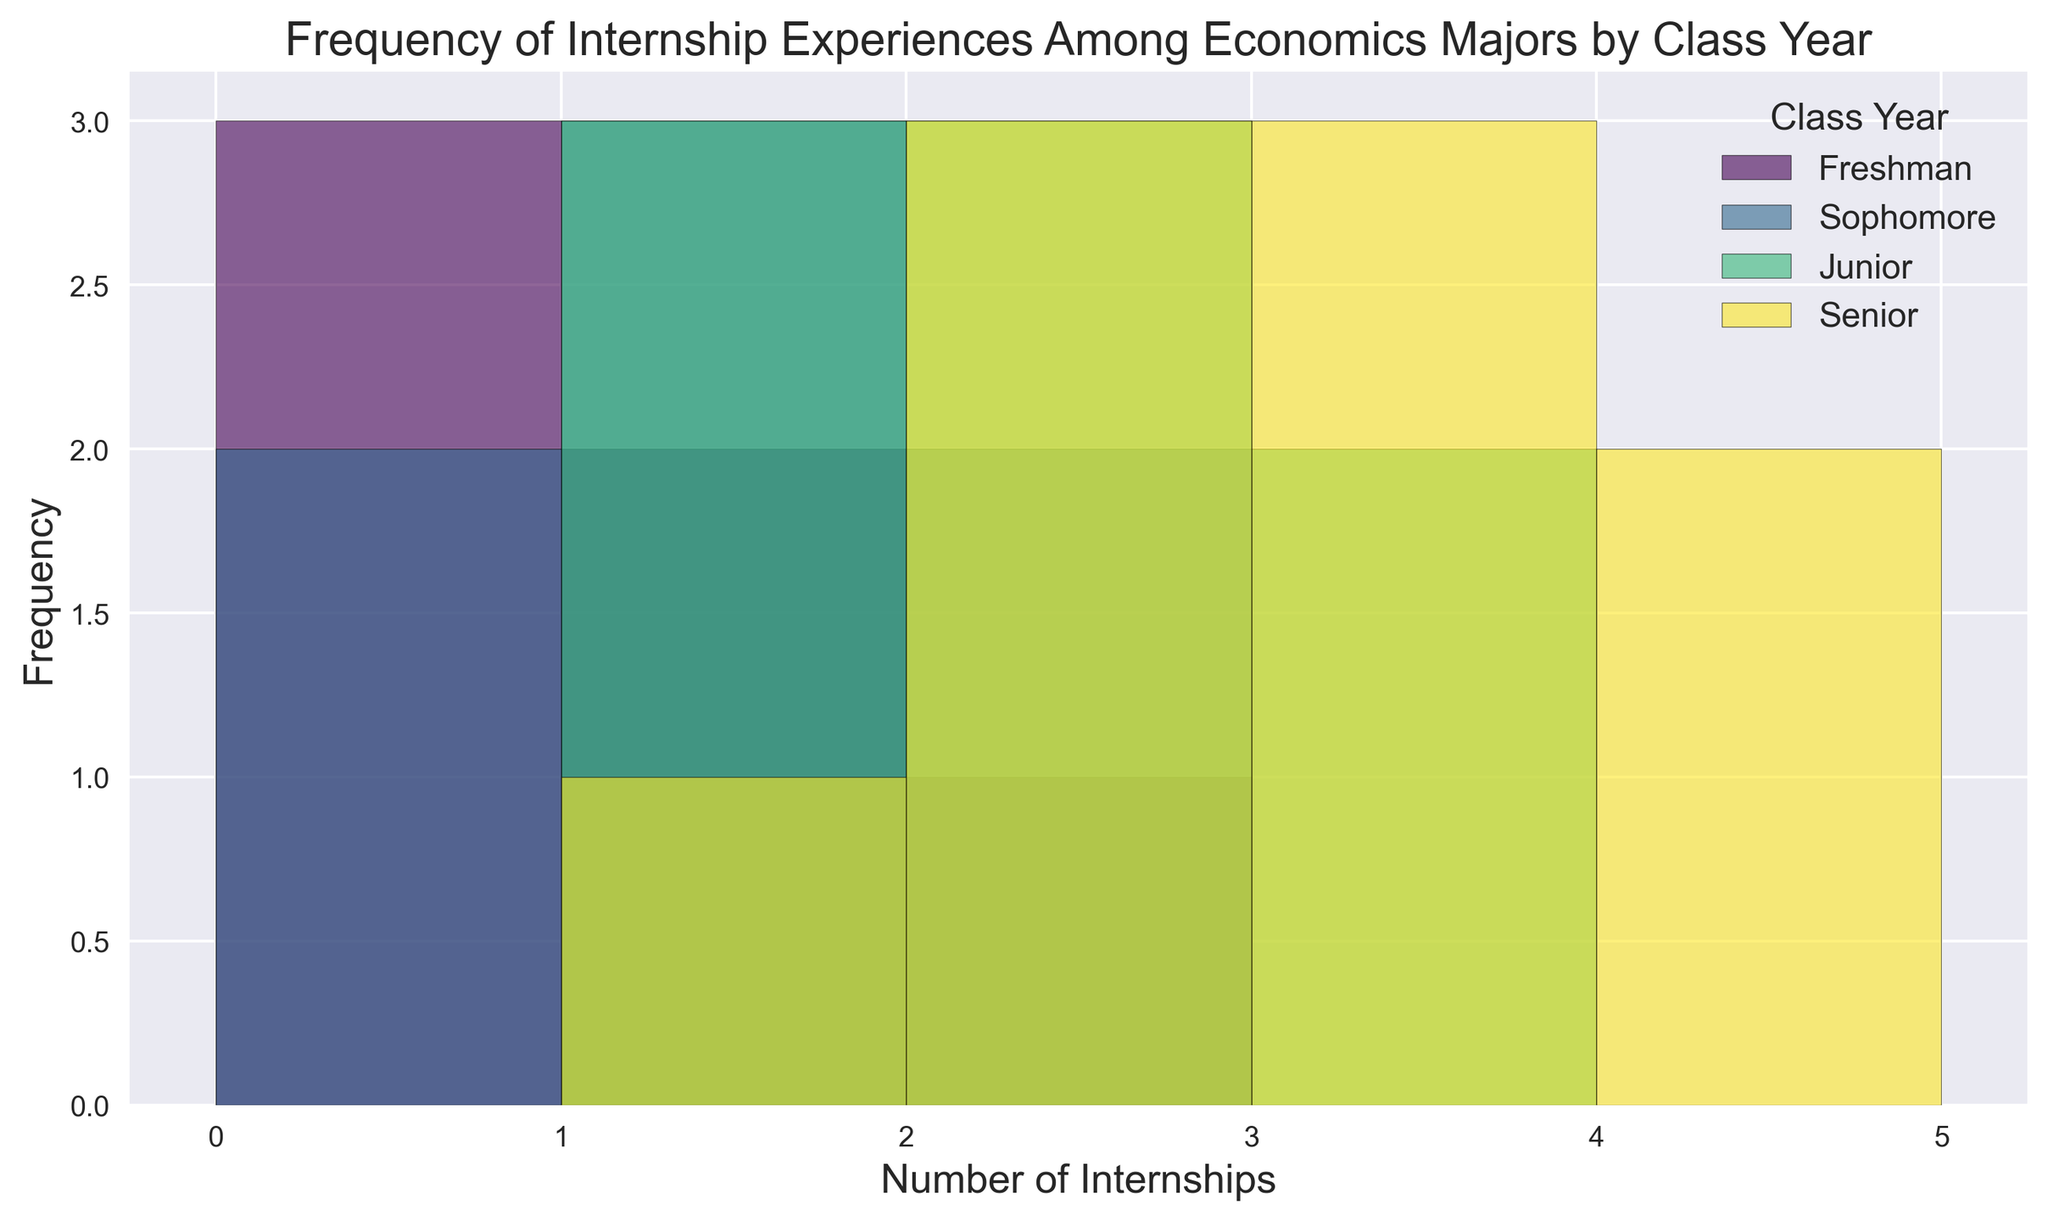How many internships did most Freshmen have? According to the histogram, the highest bar for Freshmen is at 0 internships. This means most Freshmen had 0 internships.
Answer: 0 Which class year had the highest number of students with exactly 3 internships? By visually inspecting the height of the bars at 3 internships for each class year, Seniors have the tallest bar. Therefore, Seniors had the highest number of students with exactly 3 internships.
Answer: Seniors Comparing Juniors and Seniors, which class year saw more students with at least 2 internships? To compare, look at the bars for Juniors and Seniors at 2, 3, and 4 internships. The combined heights of these bars for Seniors are higher than for Juniors, indicating more Seniors had at least 2 internships.
Answer: Seniors What's the total frequency of students who had at least 1 internship? Sum the frequencies of students having 1, 2, 3, and 4 internships across all class years. Freshmen: 1(2) + 2(1) = 3, Sophomores: 1(3) + 2(2) = 5, Juniors: 1(4) + 2(3) + 3(2) = 9, Seniors: 1(1) + 2(4) + 3(4) + 4(2) = 11. Total = 3 + 5 + 9 + 11 = 28.
Answer: 28 Do more Freshmen or Sophomores have internships? Freshmen have 1+1+1 = 3 internships. Sophomores have 1+1+2+1 = 5 internships. Thus, more Sophomores have internships.
Answer: Sophomores Which has a higher frequency: Freshmen with 0 internships or Seniors with 2 internships? Check the height of the respective bars for Freshmen at 0 internships and Seniors at 2 internships. The Freshmen's bar is higher, indicating a higher frequency for 0 internships among Freshmen.
Answer: Freshmen How many more Juniors had 2 internships compared to Freshmen? Look at the bars for Juniors and Freshmen at 2 internships. The bar for Juniors is 3, whereas for Freshmen it is 1. The difference is 3 - 1 = 2.
Answer: 2 What’s the dominant class year for students with 1 internship? Check which class year has the highest bar at 1 internship. Juniors have the tallest bar, making them the dominant class year for 1 internship.
Answer: Juniors Which group has the fewest students with 4 internships? Only Seniors have a visible bar at 4 internships, which is not present for other class years. Thus, other class years have zero students with 4 internships.
Answer: Freshmen, Sophomores, Juniors 